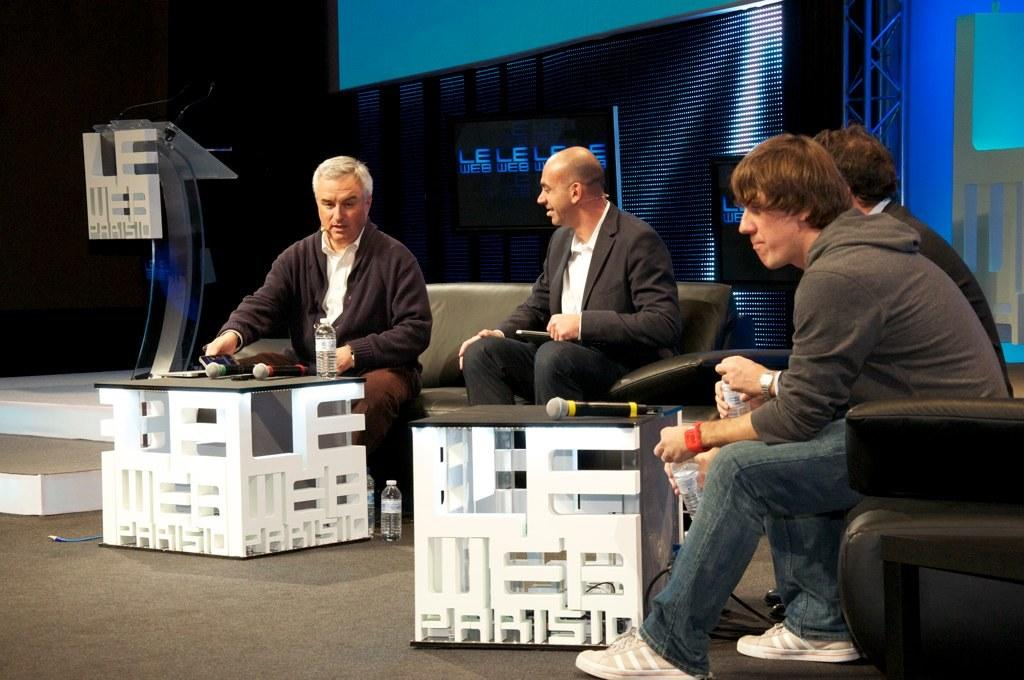<image>
Create a compact narrative representing the image presented. four men are sitting in front of a background with words LE WEB 